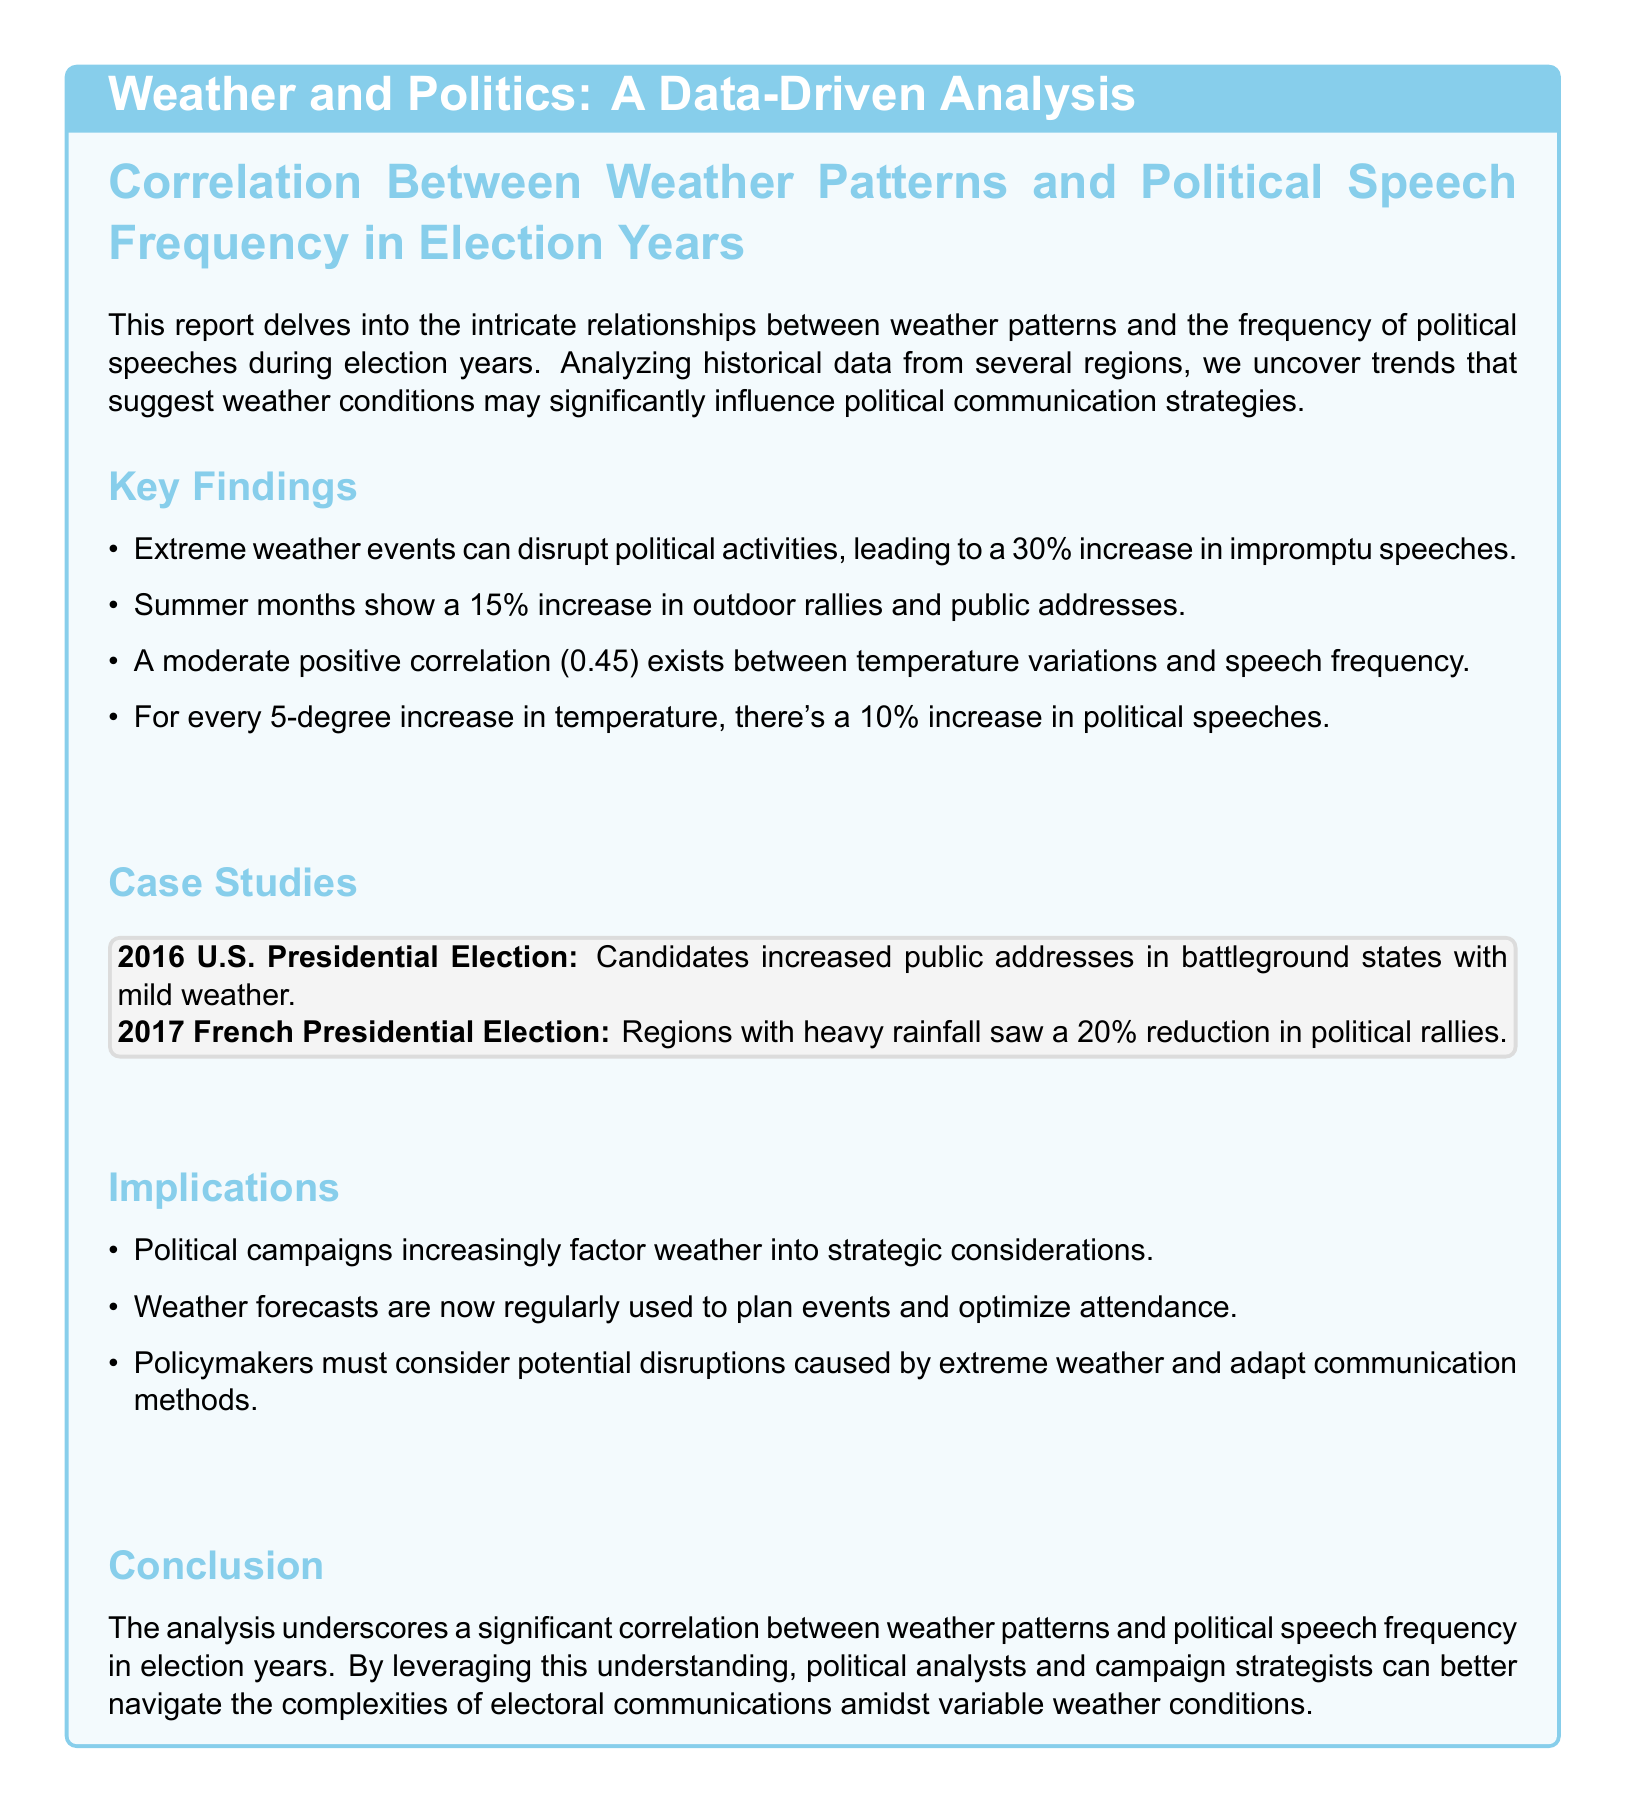What is the percentage increase in impromptu speeches due to extreme weather events? The document states that extreme weather events can disrupt political activities, leading to a 30% increase in impromptu speeches.
Answer: 30% What is the correlation value between temperature variations and speech frequency? The analysis reveals a moderate positive correlation of 0.45 exists between temperature variations and speech frequency.
Answer: 0.45 What was the percentage reduction in political rallies in regions with heavy rainfall during the 2017 French Presidential Election? The document notes that regions with heavy rainfall saw a 20% reduction in political rallies during the 2017 French Presidential Election.
Answer: 20% How much does political speech frequency increase for every 5-degree rise in temperature? It is mentioned that for every 5-degree increase in temperature, there's a 10% increase in political speeches.
Answer: 10% What strategic consideration do political campaigns increasingly factor in? The report indicates that political campaigns are increasingly factoring weather into strategic considerations.
Answer: Weather How much more do outdoor rallies and public addresses increase during summer months? The document indicates that summer months show a 15% increase in outdoor rallies and public addresses.
Answer: 15% What is the conclusion of the analysis regarding weather patterns and political speeches? The conclusion states that the analysis underscores a significant correlation between weather patterns and political speech frequency in election years.
Answer: Significant correlation What example is given for candidates increasing public addresses due to mild weather? The document references the 2016 U.S. Presidential Election as an example where candidates increased public addresses in battleground states with mild weather.
Answer: 2016 U.S. Presidential Election What should policymakers consider according to the implications section? The report suggests that policymakers must consider potential disruptions caused by extreme weather and adapt communication methods.
Answer: Potential disruptions 